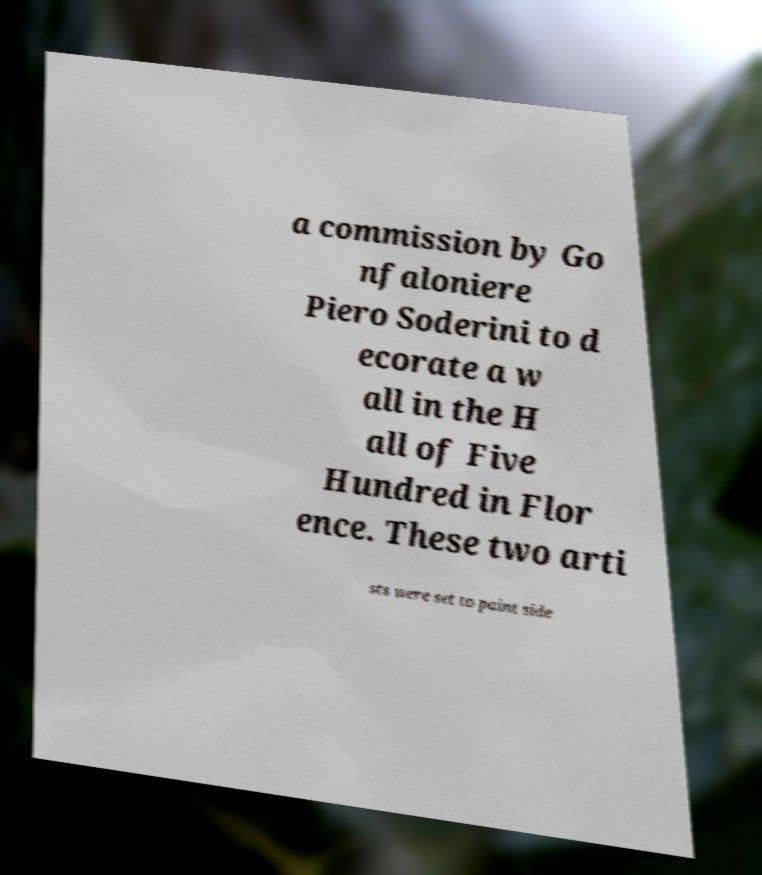Can you read and provide the text displayed in the image?This photo seems to have some interesting text. Can you extract and type it out for me? a commission by Go nfaloniere Piero Soderini to d ecorate a w all in the H all of Five Hundred in Flor ence. These two arti sts were set to paint side 